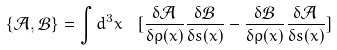Convert formula to latex. <formula><loc_0><loc_0><loc_500><loc_500>\left \{ \mathcal { A } , \mathcal { B } \right \} = \int d ^ { 3 } x \ \ [ \frac { \delta \mathcal { A } } { \delta \rho ( x ) } \frac { \delta \mathcal { B } } { \delta s ( x ) } - \frac { \delta \mathcal { B } } { \delta \rho ( x ) } \frac { \delta \mathcal { A } } { \delta s ( x ) } ]</formula> 